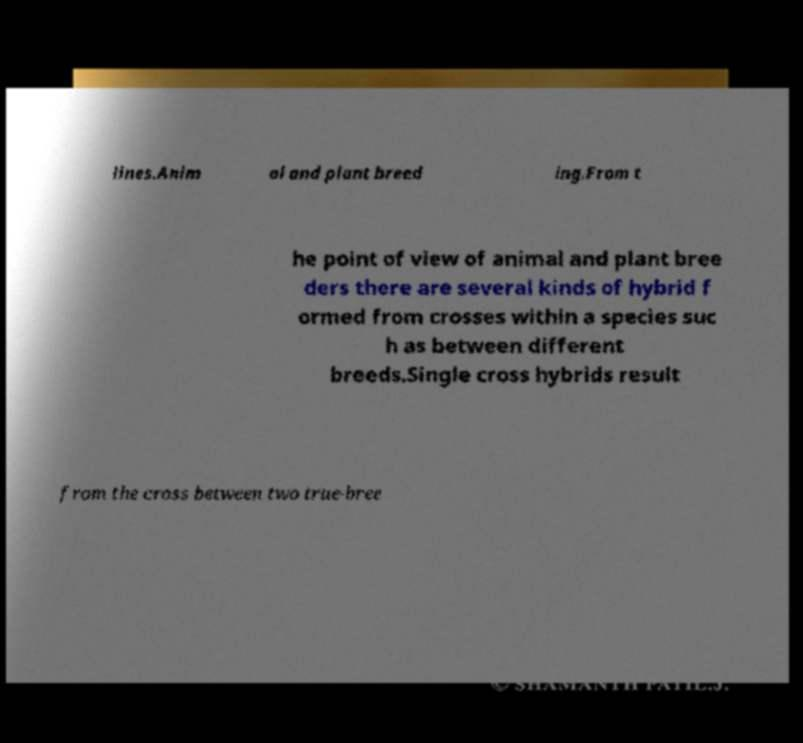Please identify and transcribe the text found in this image. lines.Anim al and plant breed ing.From t he point of view of animal and plant bree ders there are several kinds of hybrid f ormed from crosses within a species suc h as between different breeds.Single cross hybrids result from the cross between two true-bree 